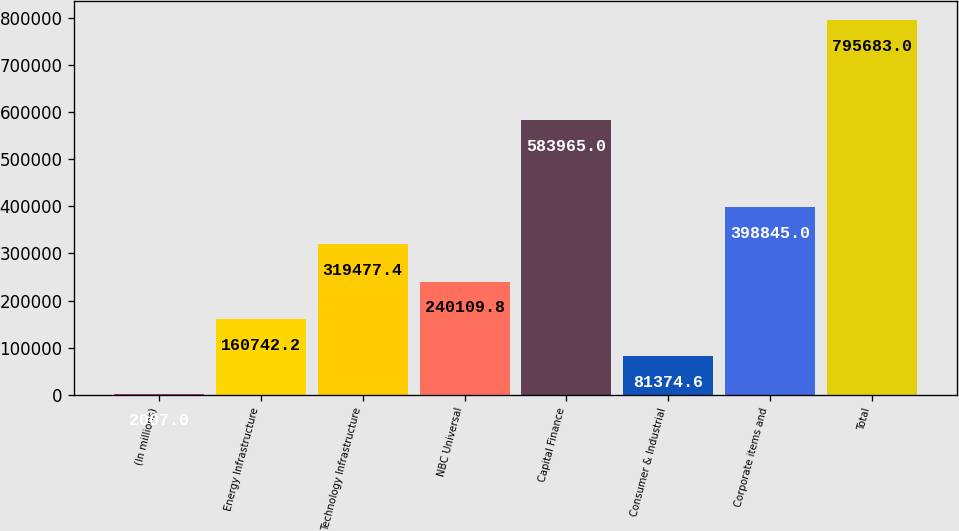Convert chart to OTSL. <chart><loc_0><loc_0><loc_500><loc_500><bar_chart><fcel>(In millions)<fcel>Energy Infrastructure<fcel>Technology Infrastructure<fcel>NBC Universal<fcel>Capital Finance<fcel>Consumer & Industrial<fcel>Corporate items and<fcel>Total<nl><fcel>2007<fcel>160742<fcel>319477<fcel>240110<fcel>583965<fcel>81374.6<fcel>398845<fcel>795683<nl></chart> 